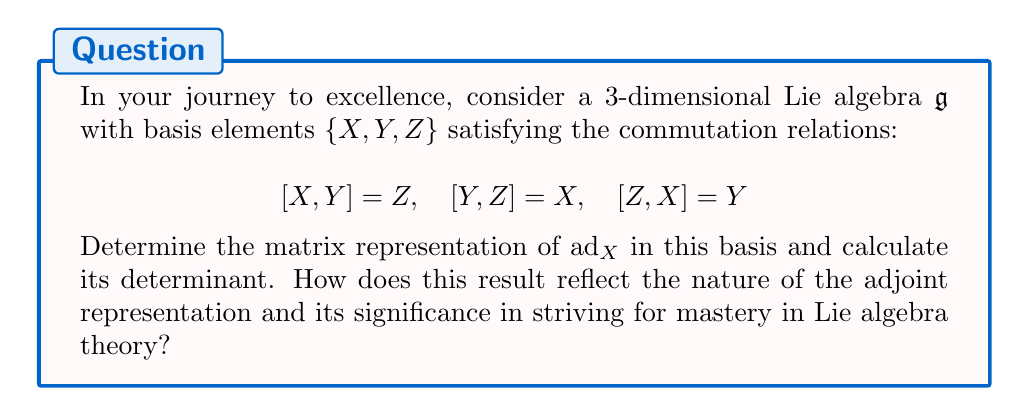Give your solution to this math problem. Let's approach this step-by-step, embracing the challenge as an opportunity for growth:

1) The adjoint representation $\text{ad}_X$ is defined by its action on the basis elements:

   $\text{ad}_X(Y) = [X,Y] = Z$
   $\text{ad}_X(Z) = [X,Z] = -Y$
   $\text{ad}_X(X) = [X,X] = 0$

2) To construct the matrix of $\text{ad}_X$, we express these results in terms of the basis:

   $\text{ad}_X(X) = 0X + 0Y + 0Z$
   $\text{ad}_X(Y) = 0X + 0Y + 1Z$
   $\text{ad}_X(Z) = 0X - 1Y + 0Z$

3) The matrix representation of $\text{ad}_X$ in the basis $\{X,Y,Z\}$ is therefore:

   $$\text{ad}_X = \begin{pmatrix}
   0 & 0 & 0 \\
   0 & 0 & -1 \\
   0 & 1 & 0
   \end{pmatrix}$$

4) To calculate the determinant, we can use the Laplace expansion along the first row:

   $\det(\text{ad}_X) = 0 \cdot (0 \cdot 0 - (-1) \cdot 1) - 0 \cdot (0 \cdot 0 - 0 \cdot (-1)) + 0 \cdot (0 \cdot 1 - 0 \cdot 0) = 0$

5) The zero determinant indicates that $\text{ad}_X$ is not invertible, which is a general property of the adjoint representation for any element of a Lie algebra.

6) This result reflects the nilpotency of the adjoint representation, a fundamental property in Lie algebra theory. It demonstrates that repeated application of $\text{ad}_X$ eventually leads to zero, embodying the concept of infinitesimal transformations.

7) The nilpotency of $\text{ad}_X$ is crucial in the study of Lie groups and their exponential maps, connecting the algebra to the group structure.

This exploration showcases the depth and interconnectedness of Lie algebra theory, encouraging us to delve deeper and strive for a comprehensive understanding of these mathematical structures.
Answer: The matrix representation of $\text{ad}_X$ is:

$$\text{ad}_X = \begin{pmatrix}
0 & 0 & 0 \\
0 & 0 & -1 \\
0 & 1 & 0
\end{pmatrix}$$

Its determinant is 0, reflecting the nilpotency of the adjoint representation, a fundamental property in Lie algebra theory. 